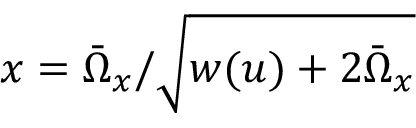Convert formula to latex. <formula><loc_0><loc_0><loc_500><loc_500>x = \bar { \Omega } _ { x } / \sqrt { w ( u ) + 2 \bar { \Omega } _ { x } }</formula> 